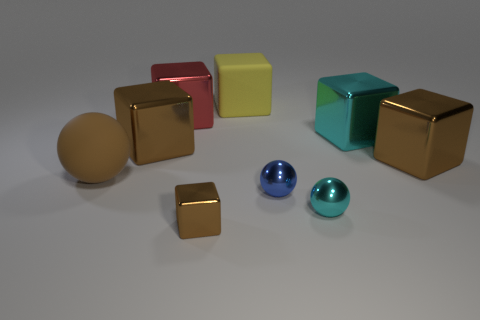Subtract all large brown matte spheres. How many spheres are left? 2 Subtract all brown balls. How many balls are left? 2 Subtract all balls. How many objects are left? 6 Subtract 2 balls. How many balls are left? 1 Subtract all purple blocks. Subtract all brown balls. How many blocks are left? 6 Subtract all blue blocks. How many gray balls are left? 0 Subtract all large cyan cubes. Subtract all large blue objects. How many objects are left? 8 Add 2 brown objects. How many brown objects are left? 6 Add 4 large cyan blocks. How many large cyan blocks exist? 5 Add 1 tiny gray things. How many objects exist? 10 